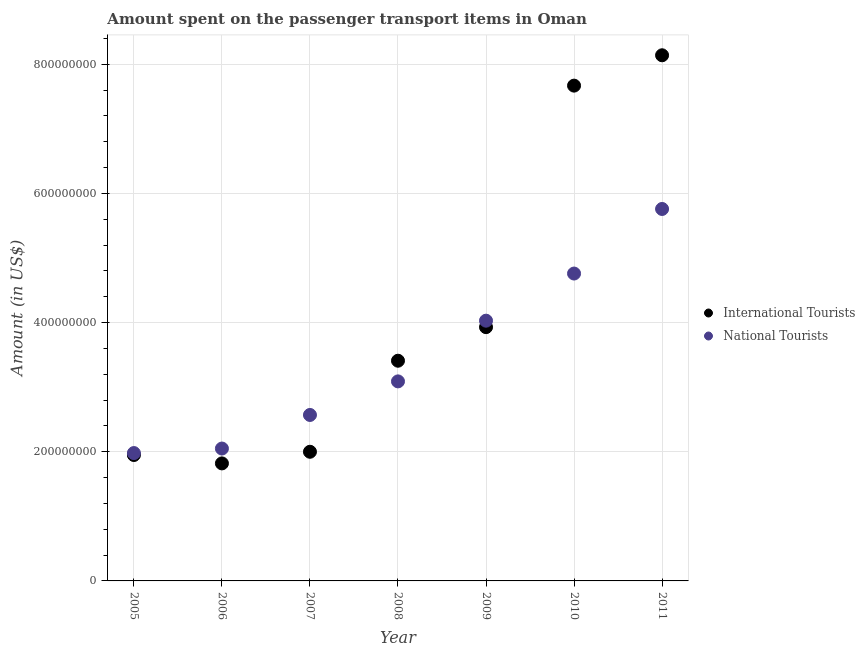How many different coloured dotlines are there?
Offer a terse response. 2. What is the amount spent on transport items of national tourists in 2006?
Provide a short and direct response. 2.05e+08. Across all years, what is the maximum amount spent on transport items of national tourists?
Keep it short and to the point. 5.76e+08. Across all years, what is the minimum amount spent on transport items of national tourists?
Give a very brief answer. 1.98e+08. In which year was the amount spent on transport items of international tourists maximum?
Offer a terse response. 2011. What is the total amount spent on transport items of international tourists in the graph?
Offer a very short reply. 2.89e+09. What is the difference between the amount spent on transport items of national tourists in 2008 and that in 2009?
Your answer should be compact. -9.40e+07. What is the difference between the amount spent on transport items of national tourists in 2010 and the amount spent on transport items of international tourists in 2008?
Offer a terse response. 1.35e+08. What is the average amount spent on transport items of international tourists per year?
Ensure brevity in your answer.  4.13e+08. In the year 2008, what is the difference between the amount spent on transport items of international tourists and amount spent on transport items of national tourists?
Your response must be concise. 3.20e+07. In how many years, is the amount spent on transport items of international tourists greater than 280000000 US$?
Your response must be concise. 4. What is the ratio of the amount spent on transport items of national tourists in 2005 to that in 2008?
Your answer should be compact. 0.64. Is the amount spent on transport items of national tourists in 2007 less than that in 2010?
Make the answer very short. Yes. Is the difference between the amount spent on transport items of international tourists in 2009 and 2011 greater than the difference between the amount spent on transport items of national tourists in 2009 and 2011?
Ensure brevity in your answer.  No. What is the difference between the highest and the second highest amount spent on transport items of international tourists?
Keep it short and to the point. 4.70e+07. What is the difference between the highest and the lowest amount spent on transport items of international tourists?
Offer a terse response. 6.32e+08. Does the amount spent on transport items of national tourists monotonically increase over the years?
Offer a very short reply. Yes. Is the amount spent on transport items of national tourists strictly greater than the amount spent on transport items of international tourists over the years?
Your response must be concise. No. How many dotlines are there?
Keep it short and to the point. 2. How many years are there in the graph?
Provide a short and direct response. 7. What is the difference between two consecutive major ticks on the Y-axis?
Your answer should be very brief. 2.00e+08. Are the values on the major ticks of Y-axis written in scientific E-notation?
Your answer should be very brief. No. Does the graph contain grids?
Offer a very short reply. Yes. What is the title of the graph?
Provide a succinct answer. Amount spent on the passenger transport items in Oman. What is the label or title of the X-axis?
Offer a very short reply. Year. What is the label or title of the Y-axis?
Keep it short and to the point. Amount (in US$). What is the Amount (in US$) of International Tourists in 2005?
Your answer should be very brief. 1.95e+08. What is the Amount (in US$) in National Tourists in 2005?
Ensure brevity in your answer.  1.98e+08. What is the Amount (in US$) in International Tourists in 2006?
Make the answer very short. 1.82e+08. What is the Amount (in US$) of National Tourists in 2006?
Your answer should be compact. 2.05e+08. What is the Amount (in US$) in National Tourists in 2007?
Provide a succinct answer. 2.57e+08. What is the Amount (in US$) of International Tourists in 2008?
Offer a terse response. 3.41e+08. What is the Amount (in US$) of National Tourists in 2008?
Your response must be concise. 3.09e+08. What is the Amount (in US$) in International Tourists in 2009?
Offer a terse response. 3.93e+08. What is the Amount (in US$) of National Tourists in 2009?
Provide a short and direct response. 4.03e+08. What is the Amount (in US$) in International Tourists in 2010?
Provide a succinct answer. 7.67e+08. What is the Amount (in US$) in National Tourists in 2010?
Provide a succinct answer. 4.76e+08. What is the Amount (in US$) of International Tourists in 2011?
Give a very brief answer. 8.14e+08. What is the Amount (in US$) in National Tourists in 2011?
Give a very brief answer. 5.76e+08. Across all years, what is the maximum Amount (in US$) of International Tourists?
Offer a very short reply. 8.14e+08. Across all years, what is the maximum Amount (in US$) of National Tourists?
Offer a very short reply. 5.76e+08. Across all years, what is the minimum Amount (in US$) in International Tourists?
Offer a very short reply. 1.82e+08. Across all years, what is the minimum Amount (in US$) of National Tourists?
Make the answer very short. 1.98e+08. What is the total Amount (in US$) of International Tourists in the graph?
Your answer should be very brief. 2.89e+09. What is the total Amount (in US$) in National Tourists in the graph?
Provide a short and direct response. 2.42e+09. What is the difference between the Amount (in US$) in International Tourists in 2005 and that in 2006?
Your answer should be very brief. 1.30e+07. What is the difference between the Amount (in US$) of National Tourists in 2005 and that in 2006?
Provide a succinct answer. -7.00e+06. What is the difference between the Amount (in US$) in International Tourists in 2005 and that in 2007?
Ensure brevity in your answer.  -5.00e+06. What is the difference between the Amount (in US$) in National Tourists in 2005 and that in 2007?
Provide a short and direct response. -5.90e+07. What is the difference between the Amount (in US$) in International Tourists in 2005 and that in 2008?
Offer a very short reply. -1.46e+08. What is the difference between the Amount (in US$) of National Tourists in 2005 and that in 2008?
Give a very brief answer. -1.11e+08. What is the difference between the Amount (in US$) in International Tourists in 2005 and that in 2009?
Provide a succinct answer. -1.98e+08. What is the difference between the Amount (in US$) in National Tourists in 2005 and that in 2009?
Your answer should be very brief. -2.05e+08. What is the difference between the Amount (in US$) in International Tourists in 2005 and that in 2010?
Make the answer very short. -5.72e+08. What is the difference between the Amount (in US$) in National Tourists in 2005 and that in 2010?
Ensure brevity in your answer.  -2.78e+08. What is the difference between the Amount (in US$) of International Tourists in 2005 and that in 2011?
Offer a terse response. -6.19e+08. What is the difference between the Amount (in US$) in National Tourists in 2005 and that in 2011?
Offer a very short reply. -3.78e+08. What is the difference between the Amount (in US$) of International Tourists in 2006 and that in 2007?
Provide a short and direct response. -1.80e+07. What is the difference between the Amount (in US$) of National Tourists in 2006 and that in 2007?
Provide a succinct answer. -5.20e+07. What is the difference between the Amount (in US$) in International Tourists in 2006 and that in 2008?
Offer a terse response. -1.59e+08. What is the difference between the Amount (in US$) in National Tourists in 2006 and that in 2008?
Your answer should be compact. -1.04e+08. What is the difference between the Amount (in US$) of International Tourists in 2006 and that in 2009?
Give a very brief answer. -2.11e+08. What is the difference between the Amount (in US$) of National Tourists in 2006 and that in 2009?
Provide a succinct answer. -1.98e+08. What is the difference between the Amount (in US$) of International Tourists in 2006 and that in 2010?
Your answer should be compact. -5.85e+08. What is the difference between the Amount (in US$) of National Tourists in 2006 and that in 2010?
Provide a short and direct response. -2.71e+08. What is the difference between the Amount (in US$) of International Tourists in 2006 and that in 2011?
Your response must be concise. -6.32e+08. What is the difference between the Amount (in US$) of National Tourists in 2006 and that in 2011?
Make the answer very short. -3.71e+08. What is the difference between the Amount (in US$) in International Tourists in 2007 and that in 2008?
Your answer should be compact. -1.41e+08. What is the difference between the Amount (in US$) in National Tourists in 2007 and that in 2008?
Your answer should be compact. -5.20e+07. What is the difference between the Amount (in US$) of International Tourists in 2007 and that in 2009?
Give a very brief answer. -1.93e+08. What is the difference between the Amount (in US$) of National Tourists in 2007 and that in 2009?
Your answer should be very brief. -1.46e+08. What is the difference between the Amount (in US$) of International Tourists in 2007 and that in 2010?
Ensure brevity in your answer.  -5.67e+08. What is the difference between the Amount (in US$) of National Tourists in 2007 and that in 2010?
Your answer should be compact. -2.19e+08. What is the difference between the Amount (in US$) of International Tourists in 2007 and that in 2011?
Keep it short and to the point. -6.14e+08. What is the difference between the Amount (in US$) in National Tourists in 2007 and that in 2011?
Your answer should be very brief. -3.19e+08. What is the difference between the Amount (in US$) in International Tourists in 2008 and that in 2009?
Offer a very short reply. -5.20e+07. What is the difference between the Amount (in US$) of National Tourists in 2008 and that in 2009?
Provide a succinct answer. -9.40e+07. What is the difference between the Amount (in US$) in International Tourists in 2008 and that in 2010?
Your answer should be compact. -4.26e+08. What is the difference between the Amount (in US$) in National Tourists in 2008 and that in 2010?
Provide a short and direct response. -1.67e+08. What is the difference between the Amount (in US$) in International Tourists in 2008 and that in 2011?
Your response must be concise. -4.73e+08. What is the difference between the Amount (in US$) of National Tourists in 2008 and that in 2011?
Your answer should be compact. -2.67e+08. What is the difference between the Amount (in US$) of International Tourists in 2009 and that in 2010?
Make the answer very short. -3.74e+08. What is the difference between the Amount (in US$) in National Tourists in 2009 and that in 2010?
Give a very brief answer. -7.30e+07. What is the difference between the Amount (in US$) of International Tourists in 2009 and that in 2011?
Your answer should be compact. -4.21e+08. What is the difference between the Amount (in US$) in National Tourists in 2009 and that in 2011?
Your response must be concise. -1.73e+08. What is the difference between the Amount (in US$) of International Tourists in 2010 and that in 2011?
Keep it short and to the point. -4.70e+07. What is the difference between the Amount (in US$) in National Tourists in 2010 and that in 2011?
Your answer should be very brief. -1.00e+08. What is the difference between the Amount (in US$) in International Tourists in 2005 and the Amount (in US$) in National Tourists in 2006?
Your answer should be compact. -1.00e+07. What is the difference between the Amount (in US$) in International Tourists in 2005 and the Amount (in US$) in National Tourists in 2007?
Offer a very short reply. -6.20e+07. What is the difference between the Amount (in US$) of International Tourists in 2005 and the Amount (in US$) of National Tourists in 2008?
Ensure brevity in your answer.  -1.14e+08. What is the difference between the Amount (in US$) of International Tourists in 2005 and the Amount (in US$) of National Tourists in 2009?
Your answer should be compact. -2.08e+08. What is the difference between the Amount (in US$) of International Tourists in 2005 and the Amount (in US$) of National Tourists in 2010?
Your response must be concise. -2.81e+08. What is the difference between the Amount (in US$) of International Tourists in 2005 and the Amount (in US$) of National Tourists in 2011?
Offer a very short reply. -3.81e+08. What is the difference between the Amount (in US$) of International Tourists in 2006 and the Amount (in US$) of National Tourists in 2007?
Offer a terse response. -7.50e+07. What is the difference between the Amount (in US$) of International Tourists in 2006 and the Amount (in US$) of National Tourists in 2008?
Your answer should be compact. -1.27e+08. What is the difference between the Amount (in US$) of International Tourists in 2006 and the Amount (in US$) of National Tourists in 2009?
Provide a short and direct response. -2.21e+08. What is the difference between the Amount (in US$) in International Tourists in 2006 and the Amount (in US$) in National Tourists in 2010?
Give a very brief answer. -2.94e+08. What is the difference between the Amount (in US$) in International Tourists in 2006 and the Amount (in US$) in National Tourists in 2011?
Offer a terse response. -3.94e+08. What is the difference between the Amount (in US$) of International Tourists in 2007 and the Amount (in US$) of National Tourists in 2008?
Your response must be concise. -1.09e+08. What is the difference between the Amount (in US$) of International Tourists in 2007 and the Amount (in US$) of National Tourists in 2009?
Offer a terse response. -2.03e+08. What is the difference between the Amount (in US$) in International Tourists in 2007 and the Amount (in US$) in National Tourists in 2010?
Make the answer very short. -2.76e+08. What is the difference between the Amount (in US$) of International Tourists in 2007 and the Amount (in US$) of National Tourists in 2011?
Your answer should be very brief. -3.76e+08. What is the difference between the Amount (in US$) in International Tourists in 2008 and the Amount (in US$) in National Tourists in 2009?
Your answer should be very brief. -6.20e+07. What is the difference between the Amount (in US$) in International Tourists in 2008 and the Amount (in US$) in National Tourists in 2010?
Your answer should be compact. -1.35e+08. What is the difference between the Amount (in US$) of International Tourists in 2008 and the Amount (in US$) of National Tourists in 2011?
Offer a very short reply. -2.35e+08. What is the difference between the Amount (in US$) in International Tourists in 2009 and the Amount (in US$) in National Tourists in 2010?
Keep it short and to the point. -8.30e+07. What is the difference between the Amount (in US$) of International Tourists in 2009 and the Amount (in US$) of National Tourists in 2011?
Offer a terse response. -1.83e+08. What is the difference between the Amount (in US$) in International Tourists in 2010 and the Amount (in US$) in National Tourists in 2011?
Ensure brevity in your answer.  1.91e+08. What is the average Amount (in US$) of International Tourists per year?
Keep it short and to the point. 4.13e+08. What is the average Amount (in US$) in National Tourists per year?
Give a very brief answer. 3.46e+08. In the year 2006, what is the difference between the Amount (in US$) in International Tourists and Amount (in US$) in National Tourists?
Make the answer very short. -2.30e+07. In the year 2007, what is the difference between the Amount (in US$) of International Tourists and Amount (in US$) of National Tourists?
Your response must be concise. -5.70e+07. In the year 2008, what is the difference between the Amount (in US$) in International Tourists and Amount (in US$) in National Tourists?
Your response must be concise. 3.20e+07. In the year 2009, what is the difference between the Amount (in US$) in International Tourists and Amount (in US$) in National Tourists?
Offer a terse response. -1.00e+07. In the year 2010, what is the difference between the Amount (in US$) of International Tourists and Amount (in US$) of National Tourists?
Your answer should be compact. 2.91e+08. In the year 2011, what is the difference between the Amount (in US$) in International Tourists and Amount (in US$) in National Tourists?
Your answer should be compact. 2.38e+08. What is the ratio of the Amount (in US$) in International Tourists in 2005 to that in 2006?
Provide a short and direct response. 1.07. What is the ratio of the Amount (in US$) of National Tourists in 2005 to that in 2006?
Your answer should be compact. 0.97. What is the ratio of the Amount (in US$) of International Tourists in 2005 to that in 2007?
Your response must be concise. 0.97. What is the ratio of the Amount (in US$) in National Tourists in 2005 to that in 2007?
Make the answer very short. 0.77. What is the ratio of the Amount (in US$) in International Tourists in 2005 to that in 2008?
Offer a terse response. 0.57. What is the ratio of the Amount (in US$) of National Tourists in 2005 to that in 2008?
Your answer should be compact. 0.64. What is the ratio of the Amount (in US$) of International Tourists in 2005 to that in 2009?
Give a very brief answer. 0.5. What is the ratio of the Amount (in US$) of National Tourists in 2005 to that in 2009?
Give a very brief answer. 0.49. What is the ratio of the Amount (in US$) of International Tourists in 2005 to that in 2010?
Offer a terse response. 0.25. What is the ratio of the Amount (in US$) of National Tourists in 2005 to that in 2010?
Your answer should be very brief. 0.42. What is the ratio of the Amount (in US$) in International Tourists in 2005 to that in 2011?
Offer a terse response. 0.24. What is the ratio of the Amount (in US$) in National Tourists in 2005 to that in 2011?
Offer a terse response. 0.34. What is the ratio of the Amount (in US$) of International Tourists in 2006 to that in 2007?
Offer a terse response. 0.91. What is the ratio of the Amount (in US$) in National Tourists in 2006 to that in 2007?
Ensure brevity in your answer.  0.8. What is the ratio of the Amount (in US$) in International Tourists in 2006 to that in 2008?
Your response must be concise. 0.53. What is the ratio of the Amount (in US$) of National Tourists in 2006 to that in 2008?
Your answer should be compact. 0.66. What is the ratio of the Amount (in US$) of International Tourists in 2006 to that in 2009?
Your answer should be compact. 0.46. What is the ratio of the Amount (in US$) in National Tourists in 2006 to that in 2009?
Provide a short and direct response. 0.51. What is the ratio of the Amount (in US$) in International Tourists in 2006 to that in 2010?
Your answer should be very brief. 0.24. What is the ratio of the Amount (in US$) of National Tourists in 2006 to that in 2010?
Ensure brevity in your answer.  0.43. What is the ratio of the Amount (in US$) in International Tourists in 2006 to that in 2011?
Your answer should be compact. 0.22. What is the ratio of the Amount (in US$) in National Tourists in 2006 to that in 2011?
Provide a short and direct response. 0.36. What is the ratio of the Amount (in US$) in International Tourists in 2007 to that in 2008?
Keep it short and to the point. 0.59. What is the ratio of the Amount (in US$) of National Tourists in 2007 to that in 2008?
Keep it short and to the point. 0.83. What is the ratio of the Amount (in US$) in International Tourists in 2007 to that in 2009?
Your answer should be very brief. 0.51. What is the ratio of the Amount (in US$) of National Tourists in 2007 to that in 2009?
Offer a very short reply. 0.64. What is the ratio of the Amount (in US$) in International Tourists in 2007 to that in 2010?
Provide a short and direct response. 0.26. What is the ratio of the Amount (in US$) of National Tourists in 2007 to that in 2010?
Offer a terse response. 0.54. What is the ratio of the Amount (in US$) in International Tourists in 2007 to that in 2011?
Keep it short and to the point. 0.25. What is the ratio of the Amount (in US$) in National Tourists in 2007 to that in 2011?
Offer a very short reply. 0.45. What is the ratio of the Amount (in US$) of International Tourists in 2008 to that in 2009?
Provide a short and direct response. 0.87. What is the ratio of the Amount (in US$) of National Tourists in 2008 to that in 2009?
Provide a short and direct response. 0.77. What is the ratio of the Amount (in US$) in International Tourists in 2008 to that in 2010?
Offer a very short reply. 0.44. What is the ratio of the Amount (in US$) in National Tourists in 2008 to that in 2010?
Offer a terse response. 0.65. What is the ratio of the Amount (in US$) in International Tourists in 2008 to that in 2011?
Provide a succinct answer. 0.42. What is the ratio of the Amount (in US$) in National Tourists in 2008 to that in 2011?
Your response must be concise. 0.54. What is the ratio of the Amount (in US$) in International Tourists in 2009 to that in 2010?
Your answer should be very brief. 0.51. What is the ratio of the Amount (in US$) in National Tourists in 2009 to that in 2010?
Your answer should be compact. 0.85. What is the ratio of the Amount (in US$) in International Tourists in 2009 to that in 2011?
Keep it short and to the point. 0.48. What is the ratio of the Amount (in US$) in National Tourists in 2009 to that in 2011?
Offer a very short reply. 0.7. What is the ratio of the Amount (in US$) in International Tourists in 2010 to that in 2011?
Your response must be concise. 0.94. What is the ratio of the Amount (in US$) in National Tourists in 2010 to that in 2011?
Keep it short and to the point. 0.83. What is the difference between the highest and the second highest Amount (in US$) in International Tourists?
Keep it short and to the point. 4.70e+07. What is the difference between the highest and the second highest Amount (in US$) in National Tourists?
Offer a very short reply. 1.00e+08. What is the difference between the highest and the lowest Amount (in US$) of International Tourists?
Your answer should be compact. 6.32e+08. What is the difference between the highest and the lowest Amount (in US$) of National Tourists?
Provide a succinct answer. 3.78e+08. 